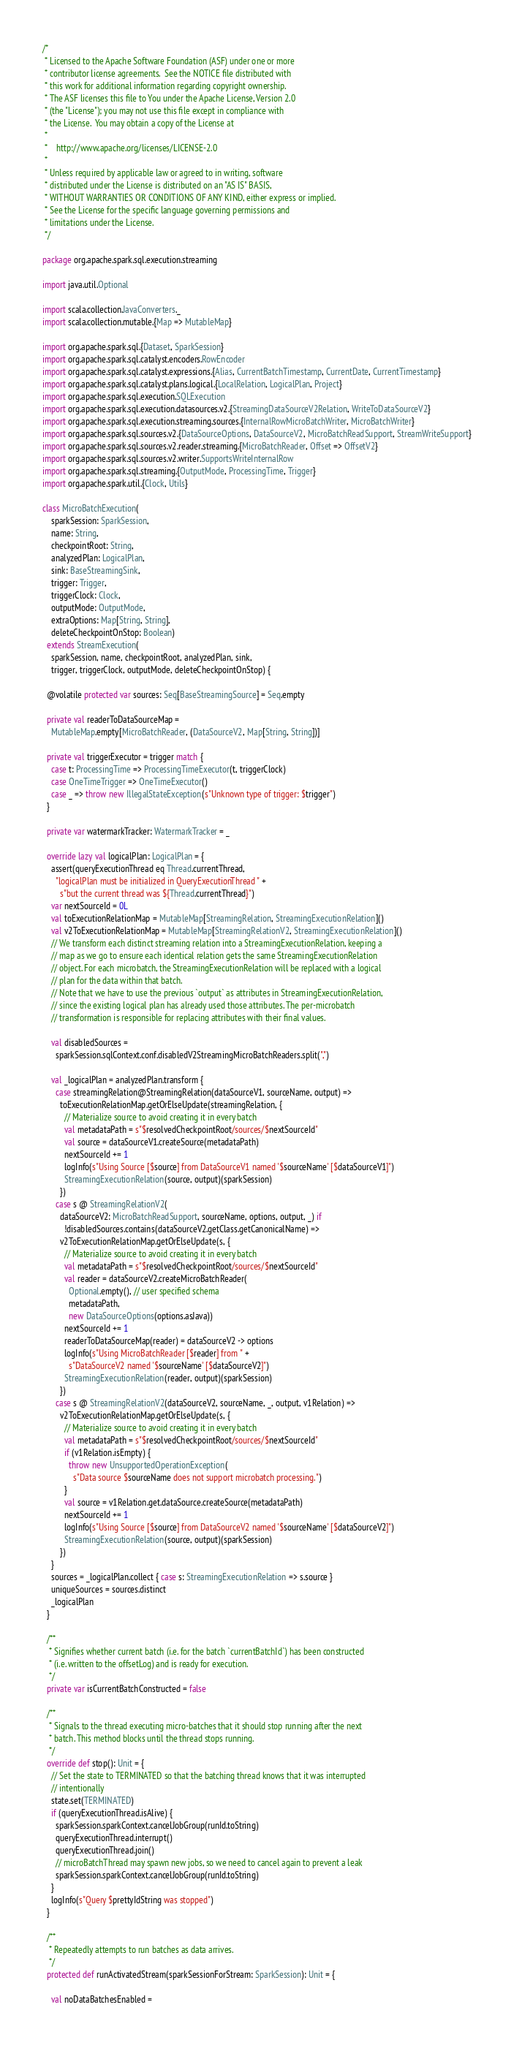Convert code to text. <code><loc_0><loc_0><loc_500><loc_500><_Scala_>/*
 * Licensed to the Apache Software Foundation (ASF) under one or more
 * contributor license agreements.  See the NOTICE file distributed with
 * this work for additional information regarding copyright ownership.
 * The ASF licenses this file to You under the Apache License, Version 2.0
 * (the "License"); you may not use this file except in compliance with
 * the License.  You may obtain a copy of the License at
 *
 *    http://www.apache.org/licenses/LICENSE-2.0
 *
 * Unless required by applicable law or agreed to in writing, software
 * distributed under the License is distributed on an "AS IS" BASIS,
 * WITHOUT WARRANTIES OR CONDITIONS OF ANY KIND, either express or implied.
 * See the License for the specific language governing permissions and
 * limitations under the License.
 */

package org.apache.spark.sql.execution.streaming

import java.util.Optional

import scala.collection.JavaConverters._
import scala.collection.mutable.{Map => MutableMap}

import org.apache.spark.sql.{Dataset, SparkSession}
import org.apache.spark.sql.catalyst.encoders.RowEncoder
import org.apache.spark.sql.catalyst.expressions.{Alias, CurrentBatchTimestamp, CurrentDate, CurrentTimestamp}
import org.apache.spark.sql.catalyst.plans.logical.{LocalRelation, LogicalPlan, Project}
import org.apache.spark.sql.execution.SQLExecution
import org.apache.spark.sql.execution.datasources.v2.{StreamingDataSourceV2Relation, WriteToDataSourceV2}
import org.apache.spark.sql.execution.streaming.sources.{InternalRowMicroBatchWriter, MicroBatchWriter}
import org.apache.spark.sql.sources.v2.{DataSourceOptions, DataSourceV2, MicroBatchReadSupport, StreamWriteSupport}
import org.apache.spark.sql.sources.v2.reader.streaming.{MicroBatchReader, Offset => OffsetV2}
import org.apache.spark.sql.sources.v2.writer.SupportsWriteInternalRow
import org.apache.spark.sql.streaming.{OutputMode, ProcessingTime, Trigger}
import org.apache.spark.util.{Clock, Utils}

class MicroBatchExecution(
    sparkSession: SparkSession,
    name: String,
    checkpointRoot: String,
    analyzedPlan: LogicalPlan,
    sink: BaseStreamingSink,
    trigger: Trigger,
    triggerClock: Clock,
    outputMode: OutputMode,
    extraOptions: Map[String, String],
    deleteCheckpointOnStop: Boolean)
  extends StreamExecution(
    sparkSession, name, checkpointRoot, analyzedPlan, sink,
    trigger, triggerClock, outputMode, deleteCheckpointOnStop) {

  @volatile protected var sources: Seq[BaseStreamingSource] = Seq.empty

  private val readerToDataSourceMap =
    MutableMap.empty[MicroBatchReader, (DataSourceV2, Map[String, String])]

  private val triggerExecutor = trigger match {
    case t: ProcessingTime => ProcessingTimeExecutor(t, triggerClock)
    case OneTimeTrigger => OneTimeExecutor()
    case _ => throw new IllegalStateException(s"Unknown type of trigger: $trigger")
  }

  private var watermarkTracker: WatermarkTracker = _

  override lazy val logicalPlan: LogicalPlan = {
    assert(queryExecutionThread eq Thread.currentThread,
      "logicalPlan must be initialized in QueryExecutionThread " +
        s"but the current thread was ${Thread.currentThread}")
    var nextSourceId = 0L
    val toExecutionRelationMap = MutableMap[StreamingRelation, StreamingExecutionRelation]()
    val v2ToExecutionRelationMap = MutableMap[StreamingRelationV2, StreamingExecutionRelation]()
    // We transform each distinct streaming relation into a StreamingExecutionRelation, keeping a
    // map as we go to ensure each identical relation gets the same StreamingExecutionRelation
    // object. For each microbatch, the StreamingExecutionRelation will be replaced with a logical
    // plan for the data within that batch.
    // Note that we have to use the previous `output` as attributes in StreamingExecutionRelation,
    // since the existing logical plan has already used those attributes. The per-microbatch
    // transformation is responsible for replacing attributes with their final values.

    val disabledSources =
      sparkSession.sqlContext.conf.disabledV2StreamingMicroBatchReaders.split(",")

    val _logicalPlan = analyzedPlan.transform {
      case streamingRelation@StreamingRelation(dataSourceV1, sourceName, output) =>
        toExecutionRelationMap.getOrElseUpdate(streamingRelation, {
          // Materialize source to avoid creating it in every batch
          val metadataPath = s"$resolvedCheckpointRoot/sources/$nextSourceId"
          val source = dataSourceV1.createSource(metadataPath)
          nextSourceId += 1
          logInfo(s"Using Source [$source] from DataSourceV1 named '$sourceName' [$dataSourceV1]")
          StreamingExecutionRelation(source, output)(sparkSession)
        })
      case s @ StreamingRelationV2(
        dataSourceV2: MicroBatchReadSupport, sourceName, options, output, _) if
          !disabledSources.contains(dataSourceV2.getClass.getCanonicalName) =>
        v2ToExecutionRelationMap.getOrElseUpdate(s, {
          // Materialize source to avoid creating it in every batch
          val metadataPath = s"$resolvedCheckpointRoot/sources/$nextSourceId"
          val reader = dataSourceV2.createMicroBatchReader(
            Optional.empty(), // user specified schema
            metadataPath,
            new DataSourceOptions(options.asJava))
          nextSourceId += 1
          readerToDataSourceMap(reader) = dataSourceV2 -> options
          logInfo(s"Using MicroBatchReader [$reader] from " +
            s"DataSourceV2 named '$sourceName' [$dataSourceV2]")
          StreamingExecutionRelation(reader, output)(sparkSession)
        })
      case s @ StreamingRelationV2(dataSourceV2, sourceName, _, output, v1Relation) =>
        v2ToExecutionRelationMap.getOrElseUpdate(s, {
          // Materialize source to avoid creating it in every batch
          val metadataPath = s"$resolvedCheckpointRoot/sources/$nextSourceId"
          if (v1Relation.isEmpty) {
            throw new UnsupportedOperationException(
              s"Data source $sourceName does not support microbatch processing.")
          }
          val source = v1Relation.get.dataSource.createSource(metadataPath)
          nextSourceId += 1
          logInfo(s"Using Source [$source] from DataSourceV2 named '$sourceName' [$dataSourceV2]")
          StreamingExecutionRelation(source, output)(sparkSession)
        })
    }
    sources = _logicalPlan.collect { case s: StreamingExecutionRelation => s.source }
    uniqueSources = sources.distinct
    _logicalPlan
  }

  /**
   * Signifies whether current batch (i.e. for the batch `currentBatchId`) has been constructed
   * (i.e. written to the offsetLog) and is ready for execution.
   */
  private var isCurrentBatchConstructed = false

  /**
   * Signals to the thread executing micro-batches that it should stop running after the next
   * batch. This method blocks until the thread stops running.
   */
  override def stop(): Unit = {
    // Set the state to TERMINATED so that the batching thread knows that it was interrupted
    // intentionally
    state.set(TERMINATED)
    if (queryExecutionThread.isAlive) {
      sparkSession.sparkContext.cancelJobGroup(runId.toString)
      queryExecutionThread.interrupt()
      queryExecutionThread.join()
      // microBatchThread may spawn new jobs, so we need to cancel again to prevent a leak
      sparkSession.sparkContext.cancelJobGroup(runId.toString)
    }
    logInfo(s"Query $prettyIdString was stopped")
  }

  /**
   * Repeatedly attempts to run batches as data arrives.
   */
  protected def runActivatedStream(sparkSessionForStream: SparkSession): Unit = {

    val noDataBatchesEnabled =</code> 